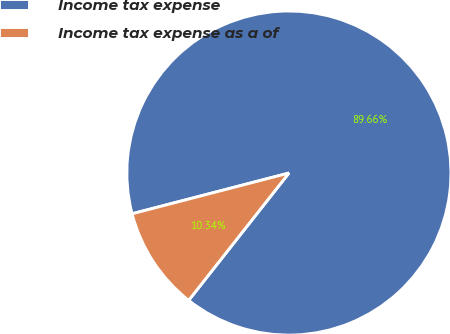Convert chart to OTSL. <chart><loc_0><loc_0><loc_500><loc_500><pie_chart><fcel>Income tax expense<fcel>Income tax expense as a of<nl><fcel>89.66%<fcel>10.34%<nl></chart> 